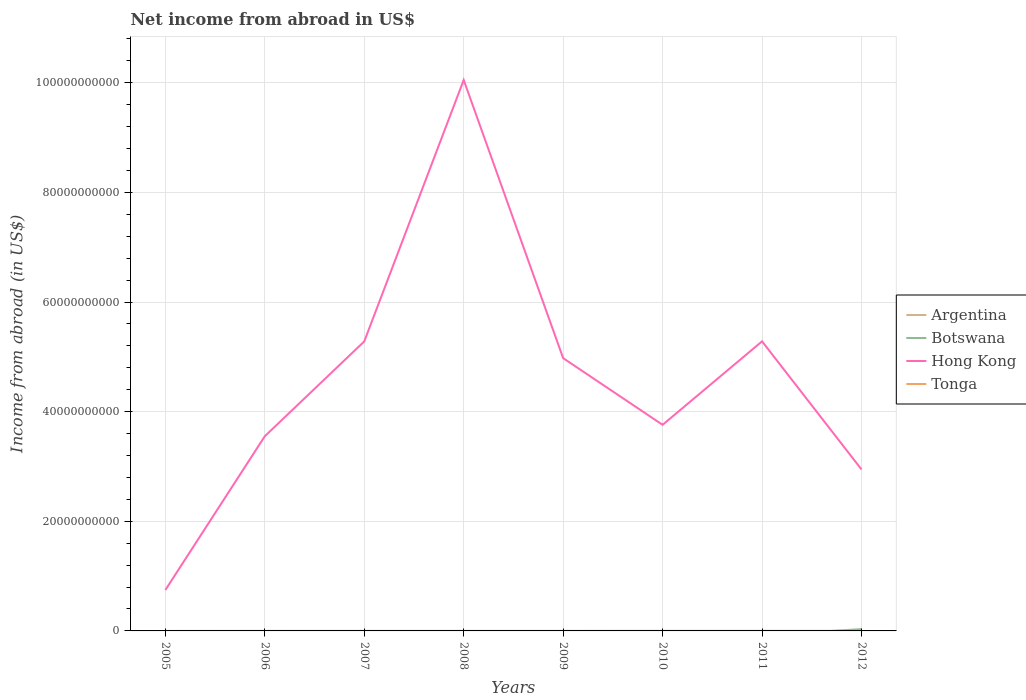Does the line corresponding to Tonga intersect with the line corresponding to Hong Kong?
Offer a very short reply. No. Is the number of lines equal to the number of legend labels?
Provide a short and direct response. No. Across all years, what is the maximum net income from abroad in Botswana?
Your response must be concise. 0. What is the total net income from abroad in Tonga in the graph?
Make the answer very short. -1.02e+07. What is the difference between the highest and the second highest net income from abroad in Botswana?
Ensure brevity in your answer.  3.31e+08. What is the difference between the highest and the lowest net income from abroad in Botswana?
Provide a succinct answer. 1. How many years are there in the graph?
Provide a short and direct response. 8. What is the difference between two consecutive major ticks on the Y-axis?
Ensure brevity in your answer.  2.00e+1. Are the values on the major ticks of Y-axis written in scientific E-notation?
Your answer should be compact. No. Does the graph contain grids?
Keep it short and to the point. Yes. Where does the legend appear in the graph?
Make the answer very short. Center right. What is the title of the graph?
Ensure brevity in your answer.  Net income from abroad in US$. Does "Paraguay" appear as one of the legend labels in the graph?
Your answer should be compact. No. What is the label or title of the X-axis?
Give a very brief answer. Years. What is the label or title of the Y-axis?
Provide a succinct answer. Income from abroad (in US$). What is the Income from abroad (in US$) of Argentina in 2005?
Your answer should be compact. 0. What is the Income from abroad (in US$) of Botswana in 2005?
Your answer should be very brief. 0. What is the Income from abroad (in US$) in Hong Kong in 2005?
Offer a very short reply. 7.46e+09. What is the Income from abroad (in US$) in Tonga in 2005?
Ensure brevity in your answer.  0. What is the Income from abroad (in US$) in Argentina in 2006?
Your answer should be compact. 0. What is the Income from abroad (in US$) of Botswana in 2006?
Your answer should be very brief. 0. What is the Income from abroad (in US$) of Hong Kong in 2006?
Offer a very short reply. 3.55e+1. What is the Income from abroad (in US$) of Tonga in 2006?
Keep it short and to the point. 1.04e+07. What is the Income from abroad (in US$) in Argentina in 2007?
Offer a very short reply. 0. What is the Income from abroad (in US$) in Botswana in 2007?
Make the answer very short. 0. What is the Income from abroad (in US$) in Hong Kong in 2007?
Ensure brevity in your answer.  5.28e+1. What is the Income from abroad (in US$) in Tonga in 2007?
Your answer should be compact. 1.44e+07. What is the Income from abroad (in US$) in Botswana in 2008?
Offer a very short reply. 0. What is the Income from abroad (in US$) of Hong Kong in 2008?
Offer a very short reply. 1.01e+11. What is the Income from abroad (in US$) in Tonga in 2008?
Ensure brevity in your answer.  1.43e+07. What is the Income from abroad (in US$) in Argentina in 2009?
Your response must be concise. 0. What is the Income from abroad (in US$) of Hong Kong in 2009?
Ensure brevity in your answer.  4.98e+1. What is the Income from abroad (in US$) in Tonga in 2009?
Give a very brief answer. 1.34e+07. What is the Income from abroad (in US$) in Botswana in 2010?
Your response must be concise. 0. What is the Income from abroad (in US$) in Hong Kong in 2010?
Provide a short and direct response. 3.76e+1. What is the Income from abroad (in US$) in Tonga in 2010?
Make the answer very short. 2.26e+07. What is the Income from abroad (in US$) in Argentina in 2011?
Provide a succinct answer. 0. What is the Income from abroad (in US$) of Botswana in 2011?
Ensure brevity in your answer.  0. What is the Income from abroad (in US$) in Hong Kong in 2011?
Give a very brief answer. 5.28e+1. What is the Income from abroad (in US$) of Tonga in 2011?
Provide a succinct answer. 2.32e+07. What is the Income from abroad (in US$) of Botswana in 2012?
Offer a very short reply. 3.31e+08. What is the Income from abroad (in US$) in Hong Kong in 2012?
Offer a very short reply. 2.95e+1. What is the Income from abroad (in US$) in Tonga in 2012?
Ensure brevity in your answer.  2.06e+07. Across all years, what is the maximum Income from abroad (in US$) of Botswana?
Offer a terse response. 3.31e+08. Across all years, what is the maximum Income from abroad (in US$) of Hong Kong?
Your answer should be very brief. 1.01e+11. Across all years, what is the maximum Income from abroad (in US$) of Tonga?
Offer a very short reply. 2.32e+07. Across all years, what is the minimum Income from abroad (in US$) of Botswana?
Give a very brief answer. 0. Across all years, what is the minimum Income from abroad (in US$) in Hong Kong?
Keep it short and to the point. 7.46e+09. What is the total Income from abroad (in US$) of Argentina in the graph?
Make the answer very short. 0. What is the total Income from abroad (in US$) in Botswana in the graph?
Your answer should be very brief. 3.31e+08. What is the total Income from abroad (in US$) of Hong Kong in the graph?
Your answer should be very brief. 3.66e+11. What is the total Income from abroad (in US$) in Tonga in the graph?
Ensure brevity in your answer.  1.19e+08. What is the difference between the Income from abroad (in US$) in Hong Kong in 2005 and that in 2006?
Give a very brief answer. -2.81e+1. What is the difference between the Income from abroad (in US$) in Hong Kong in 2005 and that in 2007?
Provide a succinct answer. -4.53e+1. What is the difference between the Income from abroad (in US$) of Hong Kong in 2005 and that in 2008?
Give a very brief answer. -9.30e+1. What is the difference between the Income from abroad (in US$) in Hong Kong in 2005 and that in 2009?
Offer a terse response. -4.23e+1. What is the difference between the Income from abroad (in US$) of Hong Kong in 2005 and that in 2010?
Your answer should be very brief. -3.01e+1. What is the difference between the Income from abroad (in US$) of Hong Kong in 2005 and that in 2011?
Keep it short and to the point. -4.54e+1. What is the difference between the Income from abroad (in US$) of Hong Kong in 2005 and that in 2012?
Give a very brief answer. -2.20e+1. What is the difference between the Income from abroad (in US$) of Hong Kong in 2006 and that in 2007?
Provide a short and direct response. -1.73e+1. What is the difference between the Income from abroad (in US$) in Tonga in 2006 and that in 2007?
Your answer should be very brief. -3.98e+06. What is the difference between the Income from abroad (in US$) in Hong Kong in 2006 and that in 2008?
Provide a short and direct response. -6.50e+1. What is the difference between the Income from abroad (in US$) of Tonga in 2006 and that in 2008?
Provide a short and direct response. -3.86e+06. What is the difference between the Income from abroad (in US$) in Hong Kong in 2006 and that in 2009?
Provide a succinct answer. -1.42e+1. What is the difference between the Income from abroad (in US$) in Tonga in 2006 and that in 2009?
Your answer should be very brief. -2.96e+06. What is the difference between the Income from abroad (in US$) of Hong Kong in 2006 and that in 2010?
Provide a succinct answer. -2.08e+09. What is the difference between the Income from abroad (in US$) of Tonga in 2006 and that in 2010?
Your response must be concise. -1.22e+07. What is the difference between the Income from abroad (in US$) in Hong Kong in 2006 and that in 2011?
Offer a very short reply. -1.73e+1. What is the difference between the Income from abroad (in US$) in Tonga in 2006 and that in 2011?
Your response must be concise. -1.28e+07. What is the difference between the Income from abroad (in US$) of Hong Kong in 2006 and that in 2012?
Offer a very short reply. 6.06e+09. What is the difference between the Income from abroad (in US$) of Tonga in 2006 and that in 2012?
Keep it short and to the point. -1.02e+07. What is the difference between the Income from abroad (in US$) of Hong Kong in 2007 and that in 2008?
Your answer should be compact. -4.77e+1. What is the difference between the Income from abroad (in US$) in Tonga in 2007 and that in 2008?
Offer a terse response. 1.21e+05. What is the difference between the Income from abroad (in US$) in Hong Kong in 2007 and that in 2009?
Provide a short and direct response. 3.05e+09. What is the difference between the Income from abroad (in US$) of Tonga in 2007 and that in 2009?
Offer a terse response. 1.02e+06. What is the difference between the Income from abroad (in US$) of Hong Kong in 2007 and that in 2010?
Your answer should be compact. 1.52e+1. What is the difference between the Income from abroad (in US$) of Tonga in 2007 and that in 2010?
Your response must be concise. -8.23e+06. What is the difference between the Income from abroad (in US$) in Hong Kong in 2007 and that in 2011?
Offer a terse response. -1.50e+07. What is the difference between the Income from abroad (in US$) of Tonga in 2007 and that in 2011?
Give a very brief answer. -8.84e+06. What is the difference between the Income from abroad (in US$) in Hong Kong in 2007 and that in 2012?
Keep it short and to the point. 2.34e+1. What is the difference between the Income from abroad (in US$) of Tonga in 2007 and that in 2012?
Keep it short and to the point. -6.19e+06. What is the difference between the Income from abroad (in US$) of Hong Kong in 2008 and that in 2009?
Give a very brief answer. 5.07e+1. What is the difference between the Income from abroad (in US$) of Tonga in 2008 and that in 2009?
Ensure brevity in your answer.  8.98e+05. What is the difference between the Income from abroad (in US$) in Hong Kong in 2008 and that in 2010?
Give a very brief answer. 6.29e+1. What is the difference between the Income from abroad (in US$) of Tonga in 2008 and that in 2010?
Offer a very short reply. -8.35e+06. What is the difference between the Income from abroad (in US$) in Hong Kong in 2008 and that in 2011?
Provide a succinct answer. 4.77e+1. What is the difference between the Income from abroad (in US$) in Tonga in 2008 and that in 2011?
Give a very brief answer. -8.96e+06. What is the difference between the Income from abroad (in US$) in Hong Kong in 2008 and that in 2012?
Provide a succinct answer. 7.11e+1. What is the difference between the Income from abroad (in US$) in Tonga in 2008 and that in 2012?
Your answer should be very brief. -6.31e+06. What is the difference between the Income from abroad (in US$) in Hong Kong in 2009 and that in 2010?
Offer a very short reply. 1.22e+1. What is the difference between the Income from abroad (in US$) of Tonga in 2009 and that in 2010?
Offer a very short reply. -9.25e+06. What is the difference between the Income from abroad (in US$) of Hong Kong in 2009 and that in 2011?
Offer a terse response. -3.06e+09. What is the difference between the Income from abroad (in US$) in Tonga in 2009 and that in 2011?
Give a very brief answer. -9.86e+06. What is the difference between the Income from abroad (in US$) of Hong Kong in 2009 and that in 2012?
Make the answer very short. 2.03e+1. What is the difference between the Income from abroad (in US$) in Tonga in 2009 and that in 2012?
Provide a succinct answer. -7.21e+06. What is the difference between the Income from abroad (in US$) in Hong Kong in 2010 and that in 2011?
Keep it short and to the point. -1.52e+1. What is the difference between the Income from abroad (in US$) in Tonga in 2010 and that in 2011?
Provide a succinct answer. -6.10e+05. What is the difference between the Income from abroad (in US$) in Hong Kong in 2010 and that in 2012?
Your answer should be very brief. 8.14e+09. What is the difference between the Income from abroad (in US$) of Tonga in 2010 and that in 2012?
Keep it short and to the point. 2.04e+06. What is the difference between the Income from abroad (in US$) in Hong Kong in 2011 and that in 2012?
Keep it short and to the point. 2.34e+1. What is the difference between the Income from abroad (in US$) in Tonga in 2011 and that in 2012?
Provide a short and direct response. 2.65e+06. What is the difference between the Income from abroad (in US$) in Hong Kong in 2005 and the Income from abroad (in US$) in Tonga in 2006?
Give a very brief answer. 7.45e+09. What is the difference between the Income from abroad (in US$) of Hong Kong in 2005 and the Income from abroad (in US$) of Tonga in 2007?
Provide a succinct answer. 7.45e+09. What is the difference between the Income from abroad (in US$) of Hong Kong in 2005 and the Income from abroad (in US$) of Tonga in 2008?
Make the answer very short. 7.45e+09. What is the difference between the Income from abroad (in US$) in Hong Kong in 2005 and the Income from abroad (in US$) in Tonga in 2009?
Give a very brief answer. 7.45e+09. What is the difference between the Income from abroad (in US$) in Hong Kong in 2005 and the Income from abroad (in US$) in Tonga in 2010?
Make the answer very short. 7.44e+09. What is the difference between the Income from abroad (in US$) in Hong Kong in 2005 and the Income from abroad (in US$) in Tonga in 2011?
Give a very brief answer. 7.44e+09. What is the difference between the Income from abroad (in US$) in Hong Kong in 2005 and the Income from abroad (in US$) in Tonga in 2012?
Give a very brief answer. 7.44e+09. What is the difference between the Income from abroad (in US$) in Hong Kong in 2006 and the Income from abroad (in US$) in Tonga in 2007?
Make the answer very short. 3.55e+1. What is the difference between the Income from abroad (in US$) of Hong Kong in 2006 and the Income from abroad (in US$) of Tonga in 2008?
Give a very brief answer. 3.55e+1. What is the difference between the Income from abroad (in US$) in Hong Kong in 2006 and the Income from abroad (in US$) in Tonga in 2009?
Your response must be concise. 3.55e+1. What is the difference between the Income from abroad (in US$) in Hong Kong in 2006 and the Income from abroad (in US$) in Tonga in 2010?
Ensure brevity in your answer.  3.55e+1. What is the difference between the Income from abroad (in US$) of Hong Kong in 2006 and the Income from abroad (in US$) of Tonga in 2011?
Provide a short and direct response. 3.55e+1. What is the difference between the Income from abroad (in US$) of Hong Kong in 2006 and the Income from abroad (in US$) of Tonga in 2012?
Provide a succinct answer. 3.55e+1. What is the difference between the Income from abroad (in US$) of Hong Kong in 2007 and the Income from abroad (in US$) of Tonga in 2008?
Provide a succinct answer. 5.28e+1. What is the difference between the Income from abroad (in US$) in Hong Kong in 2007 and the Income from abroad (in US$) in Tonga in 2009?
Your response must be concise. 5.28e+1. What is the difference between the Income from abroad (in US$) of Hong Kong in 2007 and the Income from abroad (in US$) of Tonga in 2010?
Give a very brief answer. 5.28e+1. What is the difference between the Income from abroad (in US$) in Hong Kong in 2007 and the Income from abroad (in US$) in Tonga in 2011?
Your answer should be very brief. 5.28e+1. What is the difference between the Income from abroad (in US$) in Hong Kong in 2007 and the Income from abroad (in US$) in Tonga in 2012?
Offer a very short reply. 5.28e+1. What is the difference between the Income from abroad (in US$) in Hong Kong in 2008 and the Income from abroad (in US$) in Tonga in 2009?
Give a very brief answer. 1.00e+11. What is the difference between the Income from abroad (in US$) in Hong Kong in 2008 and the Income from abroad (in US$) in Tonga in 2010?
Your response must be concise. 1.00e+11. What is the difference between the Income from abroad (in US$) in Hong Kong in 2008 and the Income from abroad (in US$) in Tonga in 2011?
Provide a succinct answer. 1.00e+11. What is the difference between the Income from abroad (in US$) of Hong Kong in 2008 and the Income from abroad (in US$) of Tonga in 2012?
Provide a succinct answer. 1.00e+11. What is the difference between the Income from abroad (in US$) in Hong Kong in 2009 and the Income from abroad (in US$) in Tonga in 2010?
Make the answer very short. 4.97e+1. What is the difference between the Income from abroad (in US$) in Hong Kong in 2009 and the Income from abroad (in US$) in Tonga in 2011?
Offer a very short reply. 4.97e+1. What is the difference between the Income from abroad (in US$) in Hong Kong in 2009 and the Income from abroad (in US$) in Tonga in 2012?
Ensure brevity in your answer.  4.97e+1. What is the difference between the Income from abroad (in US$) in Hong Kong in 2010 and the Income from abroad (in US$) in Tonga in 2011?
Your response must be concise. 3.76e+1. What is the difference between the Income from abroad (in US$) of Hong Kong in 2010 and the Income from abroad (in US$) of Tonga in 2012?
Your response must be concise. 3.76e+1. What is the difference between the Income from abroad (in US$) of Hong Kong in 2011 and the Income from abroad (in US$) of Tonga in 2012?
Keep it short and to the point. 5.28e+1. What is the average Income from abroad (in US$) of Argentina per year?
Ensure brevity in your answer.  0. What is the average Income from abroad (in US$) in Botswana per year?
Your response must be concise. 4.14e+07. What is the average Income from abroad (in US$) in Hong Kong per year?
Offer a terse response. 4.57e+1. What is the average Income from abroad (in US$) in Tonga per year?
Provide a succinct answer. 1.48e+07. In the year 2006, what is the difference between the Income from abroad (in US$) of Hong Kong and Income from abroad (in US$) of Tonga?
Your response must be concise. 3.55e+1. In the year 2007, what is the difference between the Income from abroad (in US$) of Hong Kong and Income from abroad (in US$) of Tonga?
Your response must be concise. 5.28e+1. In the year 2008, what is the difference between the Income from abroad (in US$) of Hong Kong and Income from abroad (in US$) of Tonga?
Your response must be concise. 1.00e+11. In the year 2009, what is the difference between the Income from abroad (in US$) in Hong Kong and Income from abroad (in US$) in Tonga?
Offer a terse response. 4.97e+1. In the year 2010, what is the difference between the Income from abroad (in US$) in Hong Kong and Income from abroad (in US$) in Tonga?
Make the answer very short. 3.76e+1. In the year 2011, what is the difference between the Income from abroad (in US$) of Hong Kong and Income from abroad (in US$) of Tonga?
Your answer should be very brief. 5.28e+1. In the year 2012, what is the difference between the Income from abroad (in US$) of Botswana and Income from abroad (in US$) of Hong Kong?
Your answer should be very brief. -2.91e+1. In the year 2012, what is the difference between the Income from abroad (in US$) of Botswana and Income from abroad (in US$) of Tonga?
Offer a very short reply. 3.11e+08. In the year 2012, what is the difference between the Income from abroad (in US$) in Hong Kong and Income from abroad (in US$) in Tonga?
Offer a terse response. 2.94e+1. What is the ratio of the Income from abroad (in US$) in Hong Kong in 2005 to that in 2006?
Keep it short and to the point. 0.21. What is the ratio of the Income from abroad (in US$) in Hong Kong in 2005 to that in 2007?
Give a very brief answer. 0.14. What is the ratio of the Income from abroad (in US$) in Hong Kong in 2005 to that in 2008?
Provide a short and direct response. 0.07. What is the ratio of the Income from abroad (in US$) of Hong Kong in 2005 to that in 2009?
Provide a succinct answer. 0.15. What is the ratio of the Income from abroad (in US$) in Hong Kong in 2005 to that in 2010?
Ensure brevity in your answer.  0.2. What is the ratio of the Income from abroad (in US$) in Hong Kong in 2005 to that in 2011?
Provide a succinct answer. 0.14. What is the ratio of the Income from abroad (in US$) in Hong Kong in 2005 to that in 2012?
Offer a very short reply. 0.25. What is the ratio of the Income from abroad (in US$) in Hong Kong in 2006 to that in 2007?
Ensure brevity in your answer.  0.67. What is the ratio of the Income from abroad (in US$) in Tonga in 2006 to that in 2007?
Your answer should be very brief. 0.72. What is the ratio of the Income from abroad (in US$) of Hong Kong in 2006 to that in 2008?
Make the answer very short. 0.35. What is the ratio of the Income from abroad (in US$) in Tonga in 2006 to that in 2008?
Provide a short and direct response. 0.73. What is the ratio of the Income from abroad (in US$) in Hong Kong in 2006 to that in 2009?
Offer a terse response. 0.71. What is the ratio of the Income from abroad (in US$) in Tonga in 2006 to that in 2009?
Give a very brief answer. 0.78. What is the ratio of the Income from abroad (in US$) in Hong Kong in 2006 to that in 2010?
Provide a short and direct response. 0.94. What is the ratio of the Income from abroad (in US$) in Tonga in 2006 to that in 2010?
Make the answer very short. 0.46. What is the ratio of the Income from abroad (in US$) in Hong Kong in 2006 to that in 2011?
Provide a short and direct response. 0.67. What is the ratio of the Income from abroad (in US$) of Tonga in 2006 to that in 2011?
Provide a short and direct response. 0.45. What is the ratio of the Income from abroad (in US$) of Hong Kong in 2006 to that in 2012?
Offer a very short reply. 1.21. What is the ratio of the Income from abroad (in US$) of Tonga in 2006 to that in 2012?
Make the answer very short. 0.51. What is the ratio of the Income from abroad (in US$) in Hong Kong in 2007 to that in 2008?
Your answer should be very brief. 0.53. What is the ratio of the Income from abroad (in US$) in Tonga in 2007 to that in 2008?
Keep it short and to the point. 1.01. What is the ratio of the Income from abroad (in US$) of Hong Kong in 2007 to that in 2009?
Ensure brevity in your answer.  1.06. What is the ratio of the Income from abroad (in US$) in Tonga in 2007 to that in 2009?
Offer a terse response. 1.08. What is the ratio of the Income from abroad (in US$) of Hong Kong in 2007 to that in 2010?
Make the answer very short. 1.4. What is the ratio of the Income from abroad (in US$) of Tonga in 2007 to that in 2010?
Your answer should be very brief. 0.64. What is the ratio of the Income from abroad (in US$) of Hong Kong in 2007 to that in 2011?
Your response must be concise. 1. What is the ratio of the Income from abroad (in US$) in Tonga in 2007 to that in 2011?
Provide a short and direct response. 0.62. What is the ratio of the Income from abroad (in US$) of Hong Kong in 2007 to that in 2012?
Give a very brief answer. 1.79. What is the ratio of the Income from abroad (in US$) in Tonga in 2007 to that in 2012?
Make the answer very short. 0.7. What is the ratio of the Income from abroad (in US$) of Hong Kong in 2008 to that in 2009?
Keep it short and to the point. 2.02. What is the ratio of the Income from abroad (in US$) of Tonga in 2008 to that in 2009?
Your answer should be very brief. 1.07. What is the ratio of the Income from abroad (in US$) of Hong Kong in 2008 to that in 2010?
Give a very brief answer. 2.67. What is the ratio of the Income from abroad (in US$) in Tonga in 2008 to that in 2010?
Give a very brief answer. 0.63. What is the ratio of the Income from abroad (in US$) of Hong Kong in 2008 to that in 2011?
Offer a terse response. 1.9. What is the ratio of the Income from abroad (in US$) in Tonga in 2008 to that in 2011?
Provide a succinct answer. 0.61. What is the ratio of the Income from abroad (in US$) of Hong Kong in 2008 to that in 2012?
Your answer should be compact. 3.41. What is the ratio of the Income from abroad (in US$) in Tonga in 2008 to that in 2012?
Keep it short and to the point. 0.69. What is the ratio of the Income from abroad (in US$) of Hong Kong in 2009 to that in 2010?
Offer a terse response. 1.32. What is the ratio of the Income from abroad (in US$) of Tonga in 2009 to that in 2010?
Give a very brief answer. 0.59. What is the ratio of the Income from abroad (in US$) in Hong Kong in 2009 to that in 2011?
Ensure brevity in your answer.  0.94. What is the ratio of the Income from abroad (in US$) in Tonga in 2009 to that in 2011?
Provide a short and direct response. 0.58. What is the ratio of the Income from abroad (in US$) of Hong Kong in 2009 to that in 2012?
Give a very brief answer. 1.69. What is the ratio of the Income from abroad (in US$) in Tonga in 2009 to that in 2012?
Provide a succinct answer. 0.65. What is the ratio of the Income from abroad (in US$) in Hong Kong in 2010 to that in 2011?
Give a very brief answer. 0.71. What is the ratio of the Income from abroad (in US$) in Tonga in 2010 to that in 2011?
Your answer should be compact. 0.97. What is the ratio of the Income from abroad (in US$) of Hong Kong in 2010 to that in 2012?
Ensure brevity in your answer.  1.28. What is the ratio of the Income from abroad (in US$) of Tonga in 2010 to that in 2012?
Your response must be concise. 1.1. What is the ratio of the Income from abroad (in US$) of Hong Kong in 2011 to that in 2012?
Keep it short and to the point. 1.79. What is the ratio of the Income from abroad (in US$) in Tonga in 2011 to that in 2012?
Your response must be concise. 1.13. What is the difference between the highest and the second highest Income from abroad (in US$) in Hong Kong?
Your answer should be compact. 4.77e+1. What is the difference between the highest and the second highest Income from abroad (in US$) in Tonga?
Ensure brevity in your answer.  6.10e+05. What is the difference between the highest and the lowest Income from abroad (in US$) of Botswana?
Offer a very short reply. 3.31e+08. What is the difference between the highest and the lowest Income from abroad (in US$) of Hong Kong?
Your answer should be very brief. 9.30e+1. What is the difference between the highest and the lowest Income from abroad (in US$) in Tonga?
Ensure brevity in your answer.  2.32e+07. 